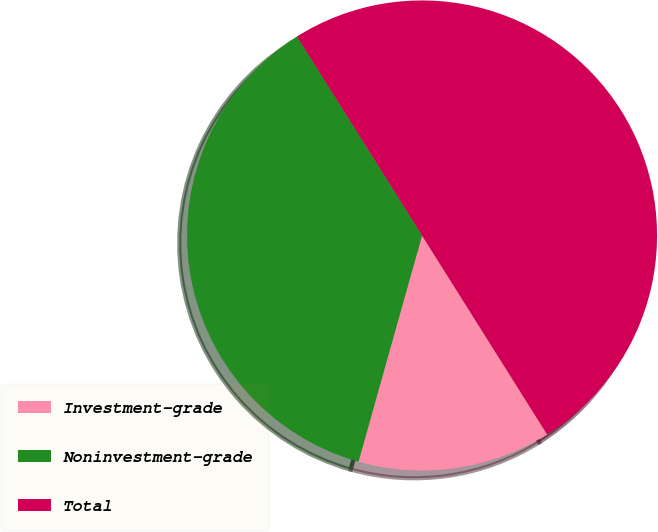<chart> <loc_0><loc_0><loc_500><loc_500><pie_chart><fcel>Investment-grade<fcel>Noninvestment-grade<fcel>Total<nl><fcel>13.29%<fcel>36.71%<fcel>50.0%<nl></chart> 